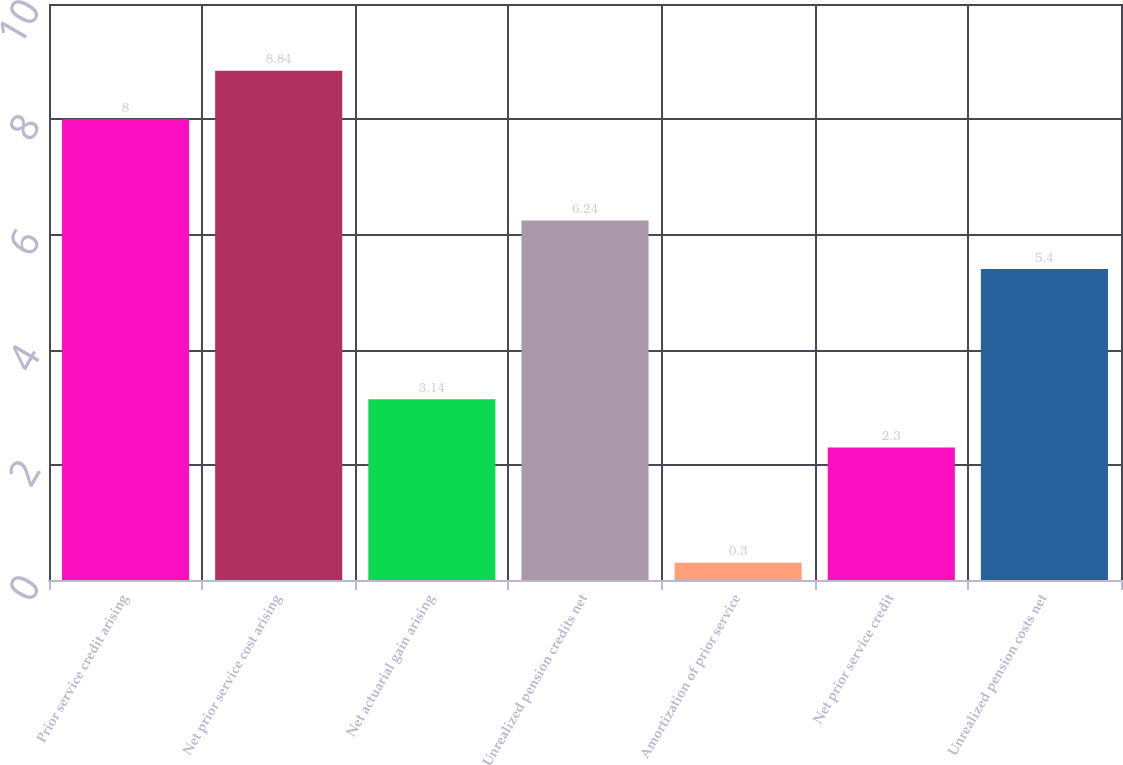Convert chart. <chart><loc_0><loc_0><loc_500><loc_500><bar_chart><fcel>Prior service credit arising<fcel>Net prior service cost arising<fcel>Net actuarial gain arising<fcel>Unrealized pension credits net<fcel>Amortization of prior service<fcel>Net prior service credit<fcel>Unrealized pension costs net<nl><fcel>8<fcel>8.84<fcel>3.14<fcel>6.24<fcel>0.3<fcel>2.3<fcel>5.4<nl></chart> 